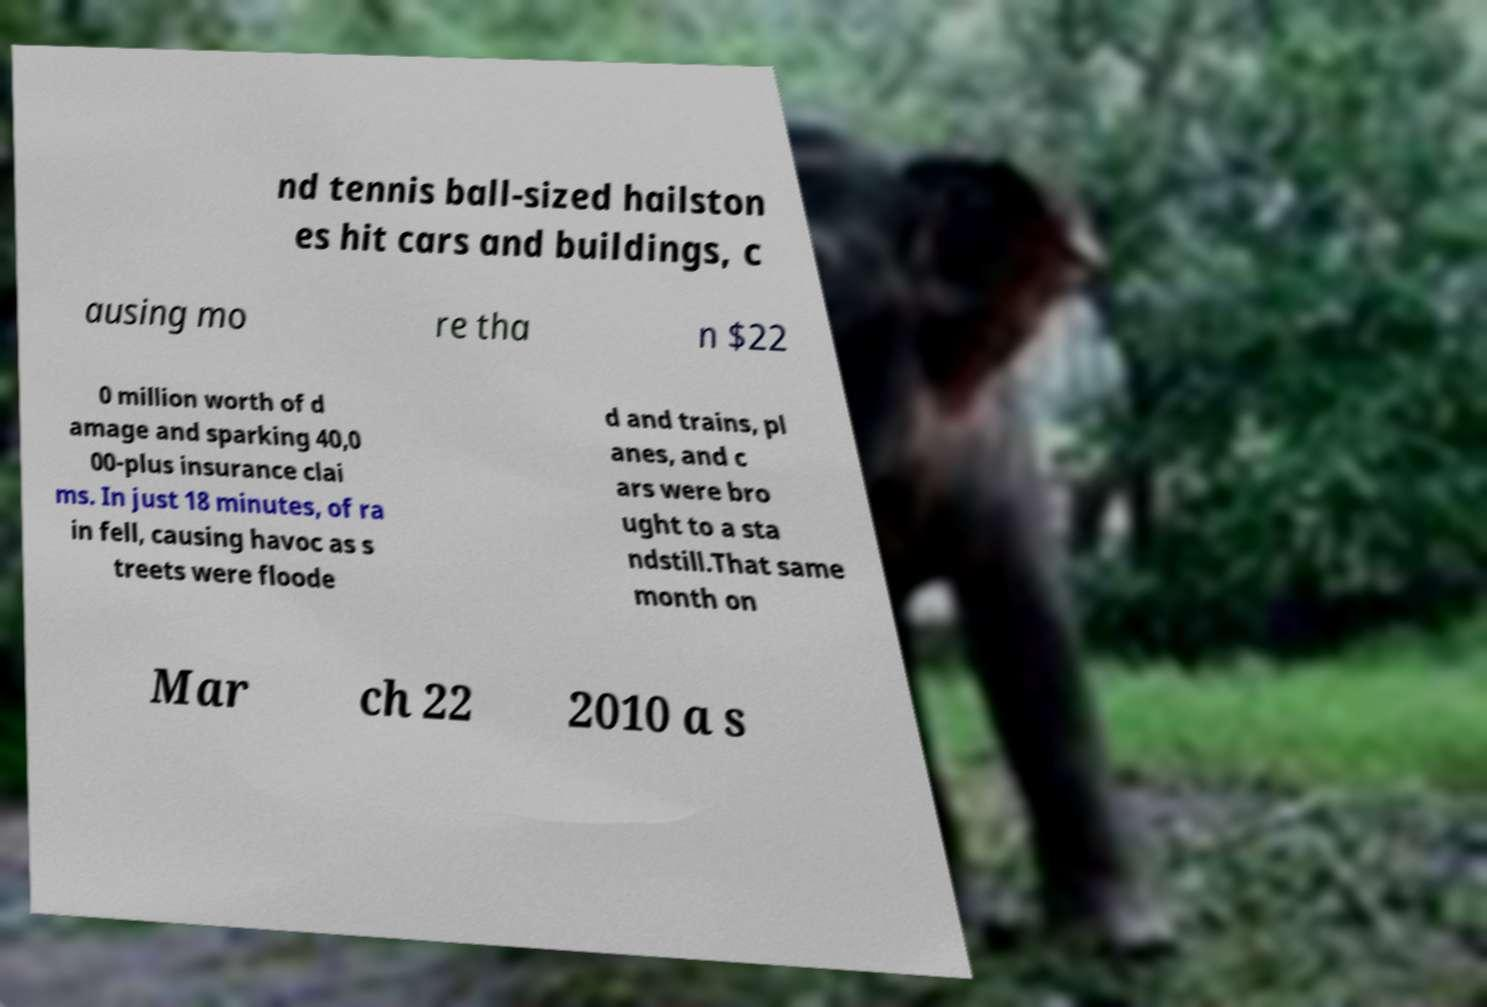Please identify and transcribe the text found in this image. nd tennis ball-sized hailston es hit cars and buildings, c ausing mo re tha n $22 0 million worth of d amage and sparking 40,0 00-plus insurance clai ms. In just 18 minutes, of ra in fell, causing havoc as s treets were floode d and trains, pl anes, and c ars were bro ught to a sta ndstill.That same month on Mar ch 22 2010 a s 